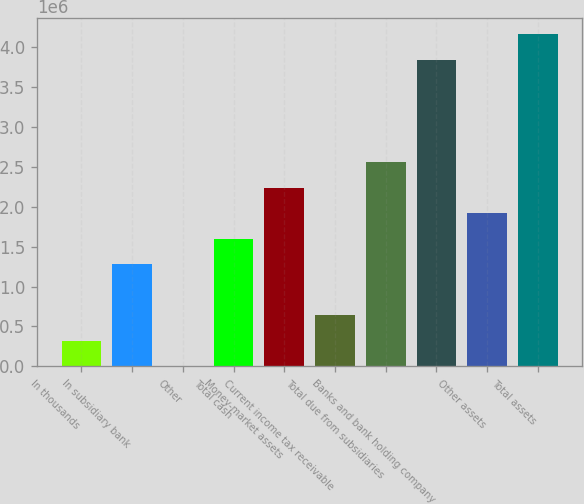<chart> <loc_0><loc_0><loc_500><loc_500><bar_chart><fcel>In thousands<fcel>In subsidiary bank<fcel>Other<fcel>Total cash<fcel>Money-market assets<fcel>Current income tax receivable<fcel>Total due from subsidiaries<fcel>Banks and bank holding company<fcel>Other assets<fcel>Total assets<nl><fcel>320346<fcel>1.28138e+06<fcel>1<fcel>1.60173e+06<fcel>2.24242e+06<fcel>640691<fcel>2.56276e+06<fcel>3.84414e+06<fcel>1.92207e+06<fcel>4.16449e+06<nl></chart> 